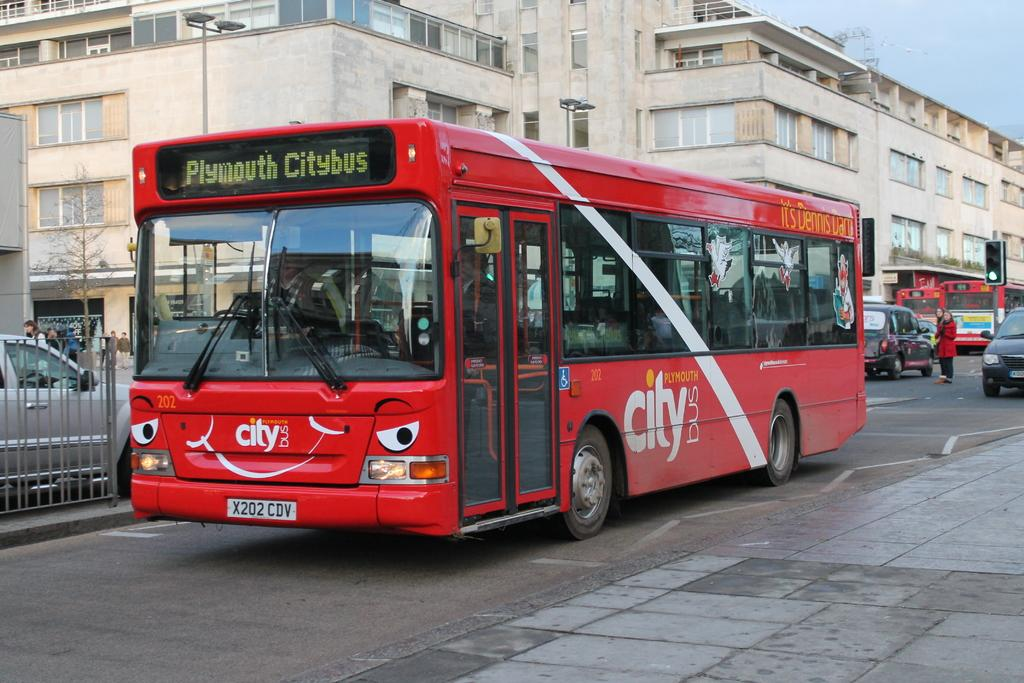<image>
Provide a brief description of the given image. A red City bus drives through the city on a crowded street 